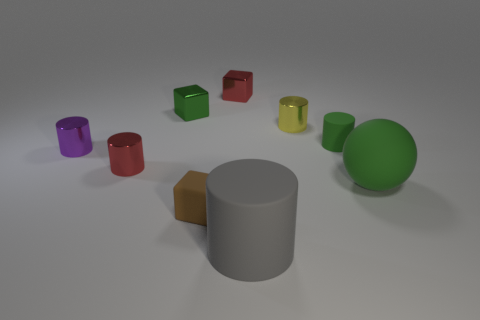What size is the yellow shiny thing that is the same shape as the purple thing?
Offer a terse response. Small. The rubber object that is the same color as the tiny matte cylinder is what size?
Offer a terse response. Large. Are there any small green objects that have the same material as the small red cube?
Provide a succinct answer. Yes. Is the number of purple metal objects greater than the number of small shiny cubes?
Make the answer very short. No. Is the brown object made of the same material as the gray cylinder?
Give a very brief answer. Yes. How many matte things are tiny green things or tiny green cylinders?
Make the answer very short. 1. There is a cylinder that is the same size as the green ball; what color is it?
Your response must be concise. Gray. What number of other small yellow objects are the same shape as the tiny yellow thing?
Keep it short and to the point. 0. How many spheres are tiny yellow shiny objects or tiny brown matte objects?
Give a very brief answer. 0. There is a tiny green thing to the left of the gray cylinder; is its shape the same as the tiny red metal thing behind the tiny purple object?
Give a very brief answer. Yes. 